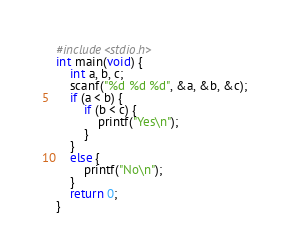<code> <loc_0><loc_0><loc_500><loc_500><_C_>#include<stdio.h>
int main(void) {
	int a, b, c;
	scanf("%d %d %d", &a, &b, &c);
	if (a < b) {
		if (b < c) {
			printf("Yes\n");
		}
	}
	else {
		printf("No\n");
	}
	return 0;
}</code> 